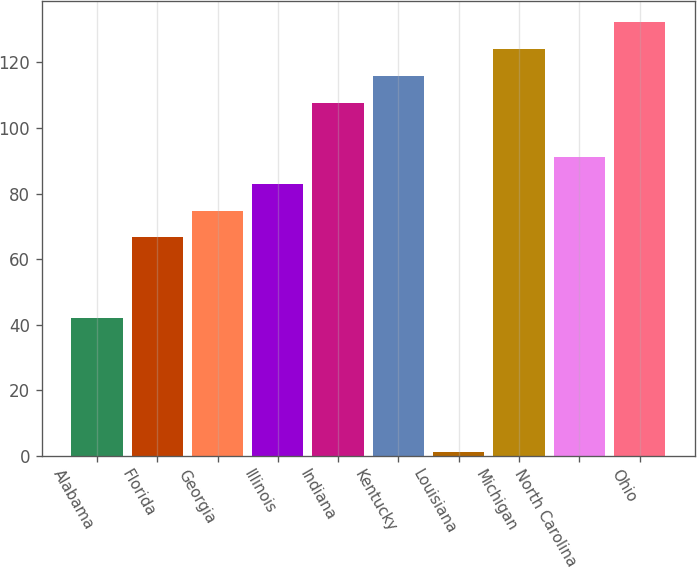Convert chart to OTSL. <chart><loc_0><loc_0><loc_500><loc_500><bar_chart><fcel>Alabama<fcel>Florida<fcel>Georgia<fcel>Illinois<fcel>Indiana<fcel>Kentucky<fcel>Louisiana<fcel>Michigan<fcel>North Carolina<fcel>Ohio<nl><fcel>42<fcel>66.6<fcel>74.8<fcel>83<fcel>107.6<fcel>115.8<fcel>1<fcel>124<fcel>91.2<fcel>132.2<nl></chart> 